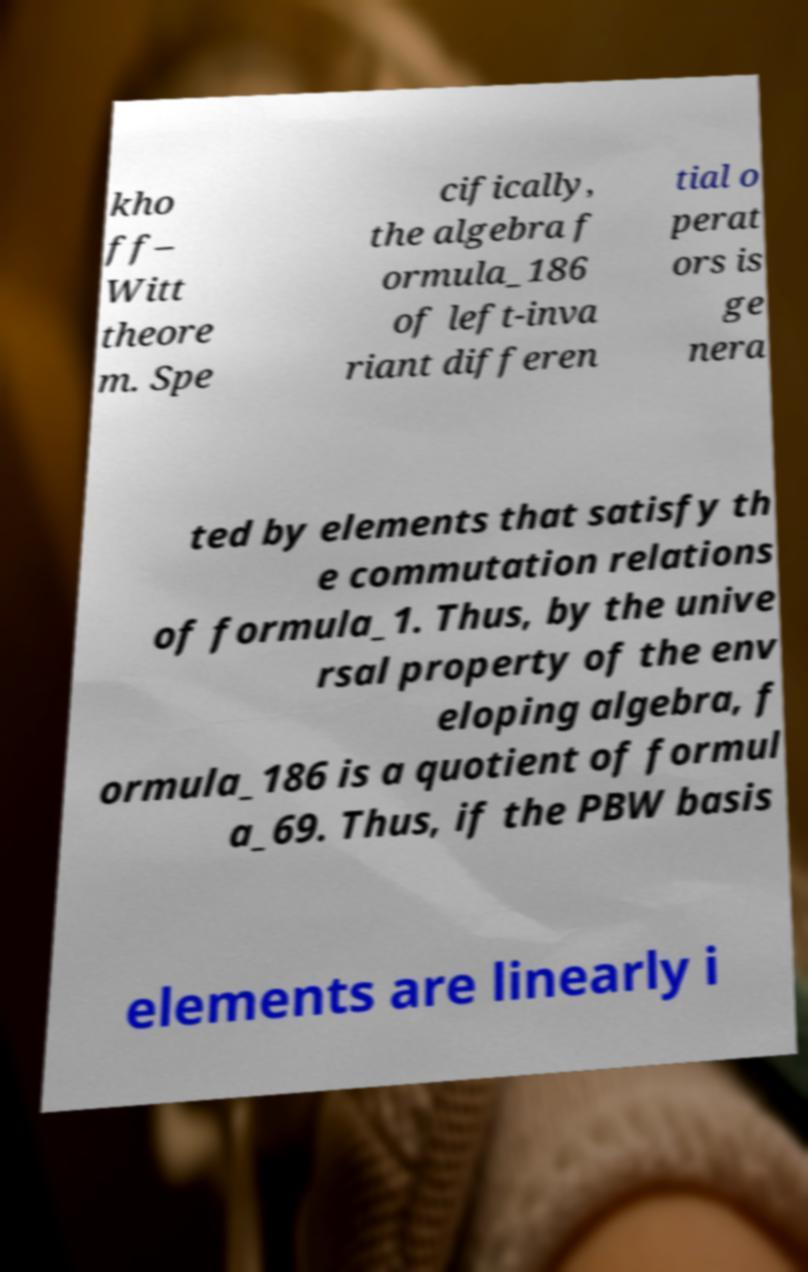Can you accurately transcribe the text from the provided image for me? kho ff– Witt theore m. Spe cifically, the algebra f ormula_186 of left-inva riant differen tial o perat ors is ge nera ted by elements that satisfy th e commutation relations of formula_1. Thus, by the unive rsal property of the env eloping algebra, f ormula_186 is a quotient of formul a_69. Thus, if the PBW basis elements are linearly i 